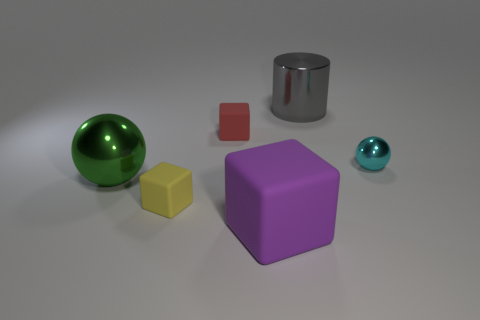Subtract all large purple matte blocks. How many blocks are left? 2 Subtract all spheres. How many objects are left? 4 Add 4 tiny yellow blocks. How many tiny yellow blocks are left? 5 Add 1 tiny red matte spheres. How many tiny red matte spheres exist? 1 Add 2 large brown rubber things. How many objects exist? 8 Subtract all red blocks. How many blocks are left? 2 Subtract 1 green balls. How many objects are left? 5 Subtract all red spheres. Subtract all yellow cylinders. How many spheres are left? 2 Subtract all gray balls. How many brown cylinders are left? 0 Subtract all tiny red metallic balls. Subtract all large purple rubber objects. How many objects are left? 5 